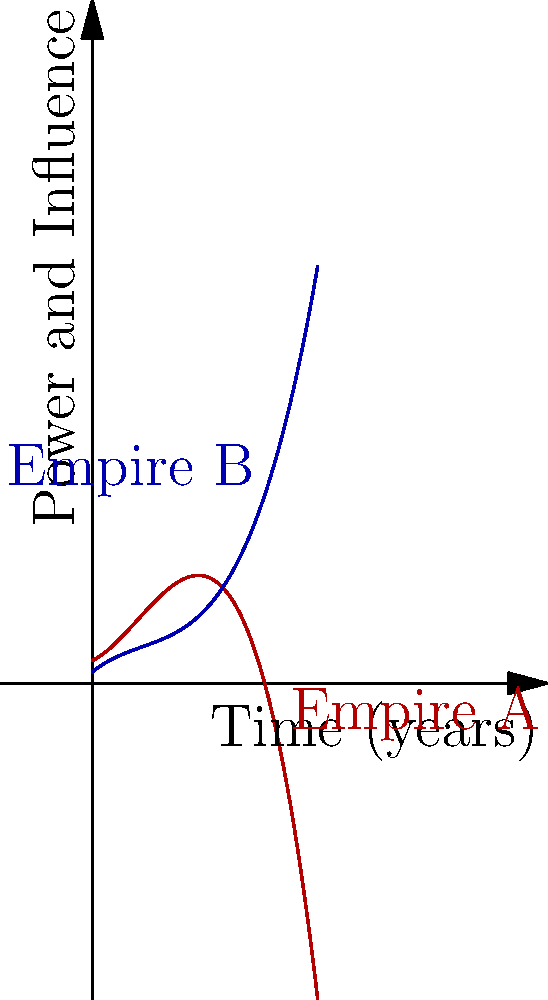The graph represents the rise and fall of two empires over a 100-year period using polynomial functions. Based on the ethical implications of imperial expansion and decline, at what point in time do the two empires have equal power and influence? What historical factors might explain this intersection point? To solve this problem, we need to follow these steps:

1. Identify the functions representing each empire:
   Empire A: $f(x) = -0.0005x^3 + 0.03x^2 + 0.5x + 10$
   Empire B: $g(x) = 0.0003x^3 - 0.02x^2 + 0.8x + 5$

2. To find the intersection point, we need to solve the equation:
   $f(x) = g(x)$

3. Substituting the functions:
   $-0.0005x^3 + 0.03x^2 + 0.5x + 10 = 0.0003x^3 - 0.02x^2 + 0.8x + 5$

4. Simplifying:
   $-0.0008x^3 + 0.05x^2 - 0.3x + 5 = 0$

5. This cubic equation can be solved using numerical methods or graphing calculators. The solution is approximately $x = 33.7$ years.

From a historical perspective, this intersection point could represent:

1. A period of power transition between the two empires.
2. A time of increased competition and potential conflict.
3. Shifting alliances or technological advancements favoring one empire over the other.
4. Changes in economic or military strategies affecting imperial influence.

Ethically, this transition raises questions about:

1. The moral implications of imperial expansion and competition.
2. The impact on local populations during power shifts.
3. The sustainability and legitimacy of imperial rule.
4. The long-term consequences of imperial policies on global development.
Answer: 33.7 years 